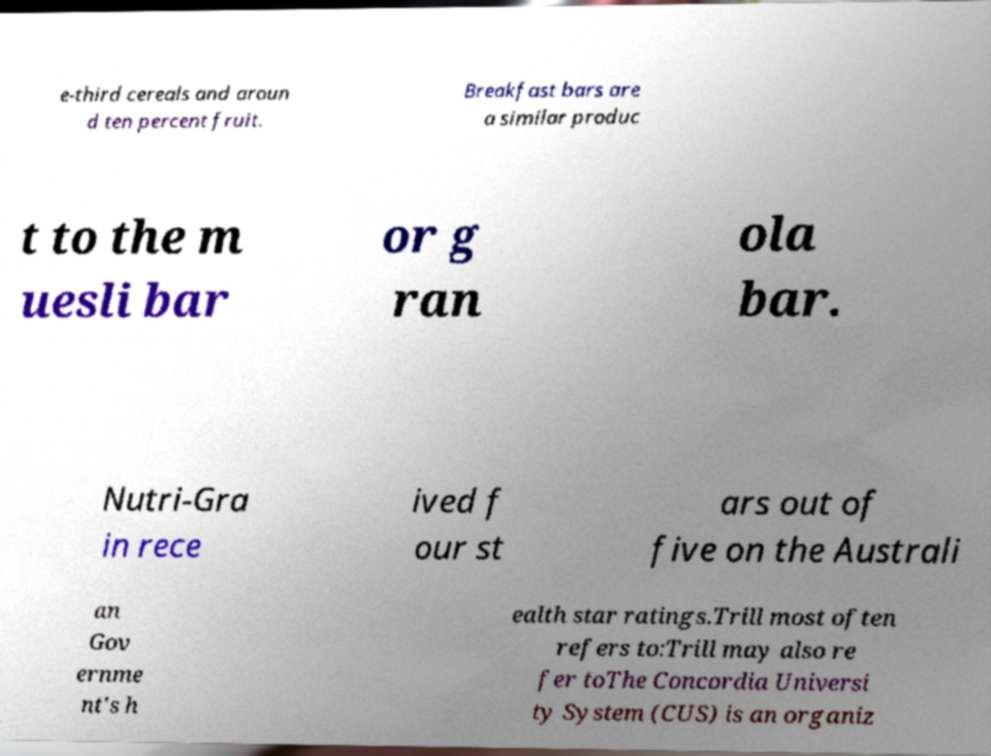I need the written content from this picture converted into text. Can you do that? e-third cereals and aroun d ten percent fruit. Breakfast bars are a similar produc t to the m uesli bar or g ran ola bar. Nutri-Gra in rece ived f our st ars out of five on the Australi an Gov ernme nt's h ealth star ratings.Trill most often refers to:Trill may also re fer toThe Concordia Universi ty System (CUS) is an organiz 